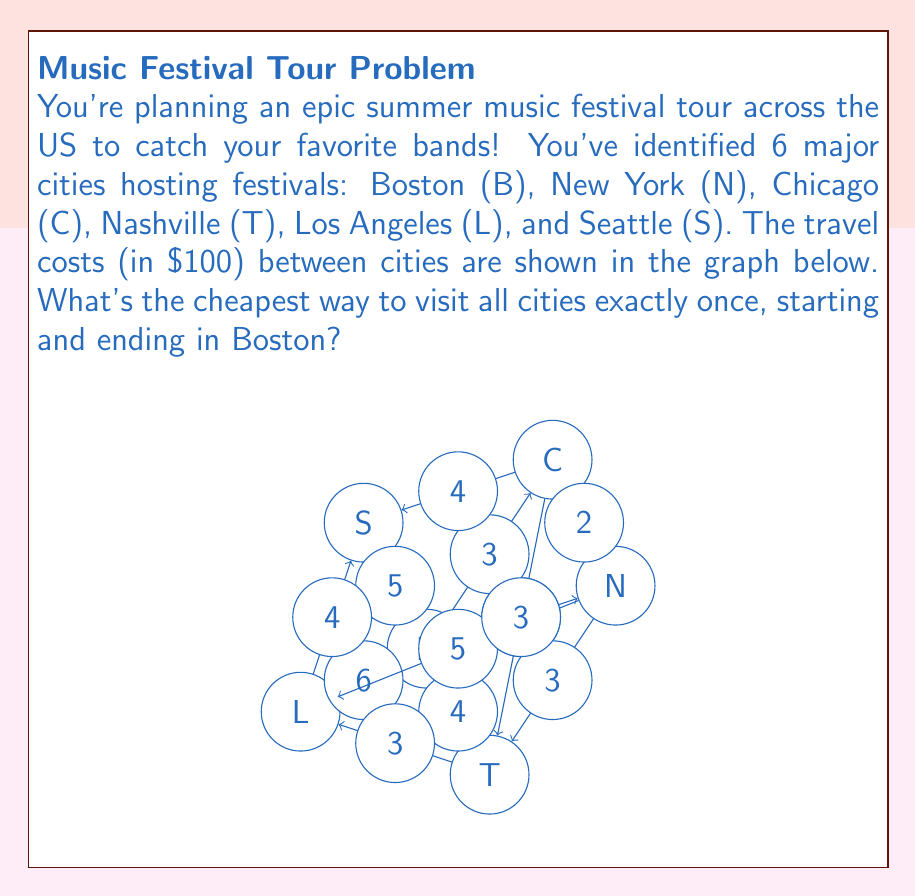Teach me how to tackle this problem. To solve this problem, we need to find the Hamiltonian cycle with the lowest total weight in the given graph. This is known as the Traveling Salesman Problem (TSP), which is NP-hard. For small graphs like this, we can use a brute-force approach:

1) List all possible tours starting and ending in Boston:
   There are $(5-1)! = 24$ possible tours.

2) Calculate the cost of each tour:
   For example, B-N-C-T-L-S-B = $2 + 2 + 3 + 3 + 4 + 5 = 19$

3) Find the tour with the minimum cost:
   After checking all 24 tours, we find that the cheapest tour is:
   B-N-C-S-L-T-B with a total cost of $2 + 2 + 4 + 4 + 3 + 4 = 19$

Therefore, the optimal path for the music festival tour is:
Boston → New York → Chicago → Seattle → Los Angeles → Nashville → Boston

The total cost is $1900 (19 * $100).

Note: In practice, for larger graphs, more efficient algorithms like dynamic programming or approximation algorithms would be used instead of brute-force.
Answer: B-N-C-S-L-T-B, $1900 